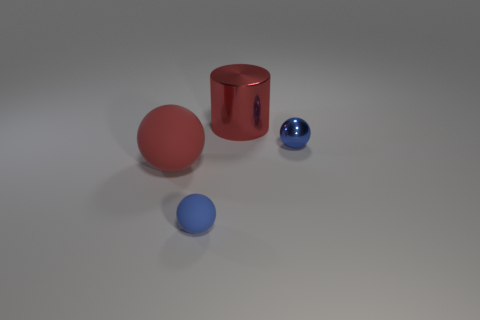There is a large sphere that is the same color as the big cylinder; what is it made of?
Your response must be concise. Rubber. Is there another green matte cylinder of the same size as the cylinder?
Give a very brief answer. No. How many tiny yellow rubber cylinders are there?
Provide a short and direct response. 0. How many tiny things are either blue matte objects or matte spheres?
Offer a very short reply. 1. There is a shiny thing that is on the left side of the tiny blue sphere to the right of the tiny blue object that is on the left side of the large red metallic cylinder; what is its color?
Keep it short and to the point. Red. What number of metallic objects are either tiny cubes or red spheres?
Make the answer very short. 0. There is a small ball in front of the small blue metallic object; is it the same color as the object that is right of the large metallic thing?
Your answer should be very brief. Yes. Are there any other things that have the same material as the red sphere?
Keep it short and to the point. Yes. There is a blue metallic object that is the same shape as the small blue rubber object; what is its size?
Keep it short and to the point. Small. Are there more cylinders that are right of the tiny blue shiny thing than purple shiny balls?
Make the answer very short. No. 